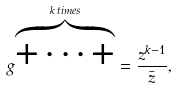<formula> <loc_0><loc_0><loc_500><loc_500>g ^ { \overbrace { + \dots + } ^ { k \, t i m e s } } = \frac { z ^ { k - 1 } } { \bar { z } } ,</formula> 